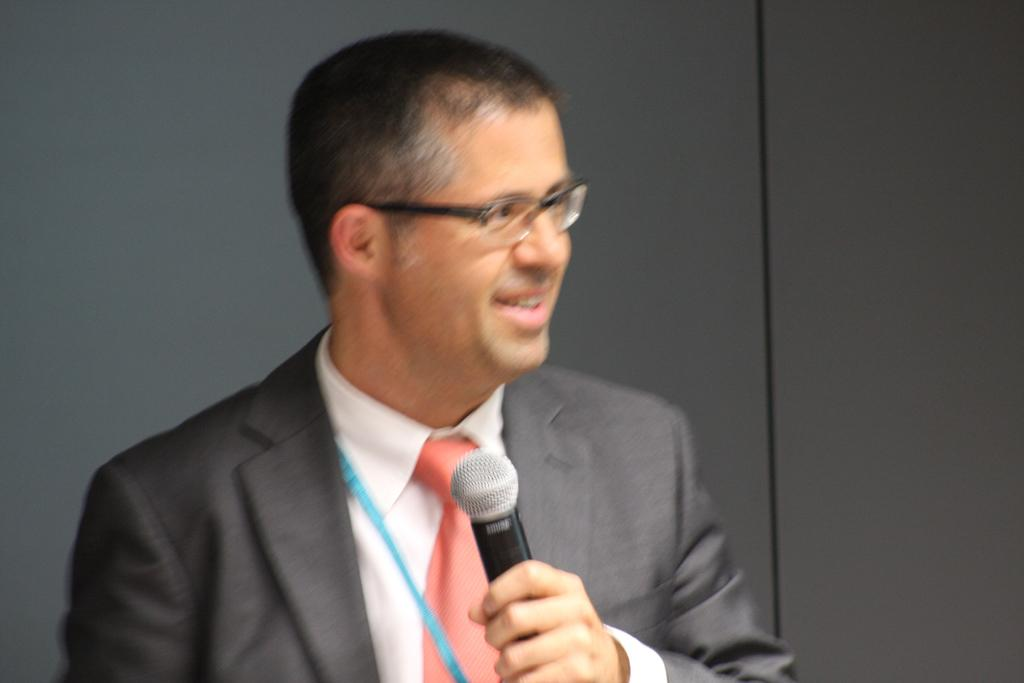Who is the main subject in the image? There is a man in the image. What is the man holding in the image? The man is holding a microphone. What is the man wearing in the image? The man is wearing a suit. What accessory is the man wearing in the image? The man has glasses. What instrument is the man playing in the image? There is: There is no instrument present in the image, and the man is not playing any instrument. 